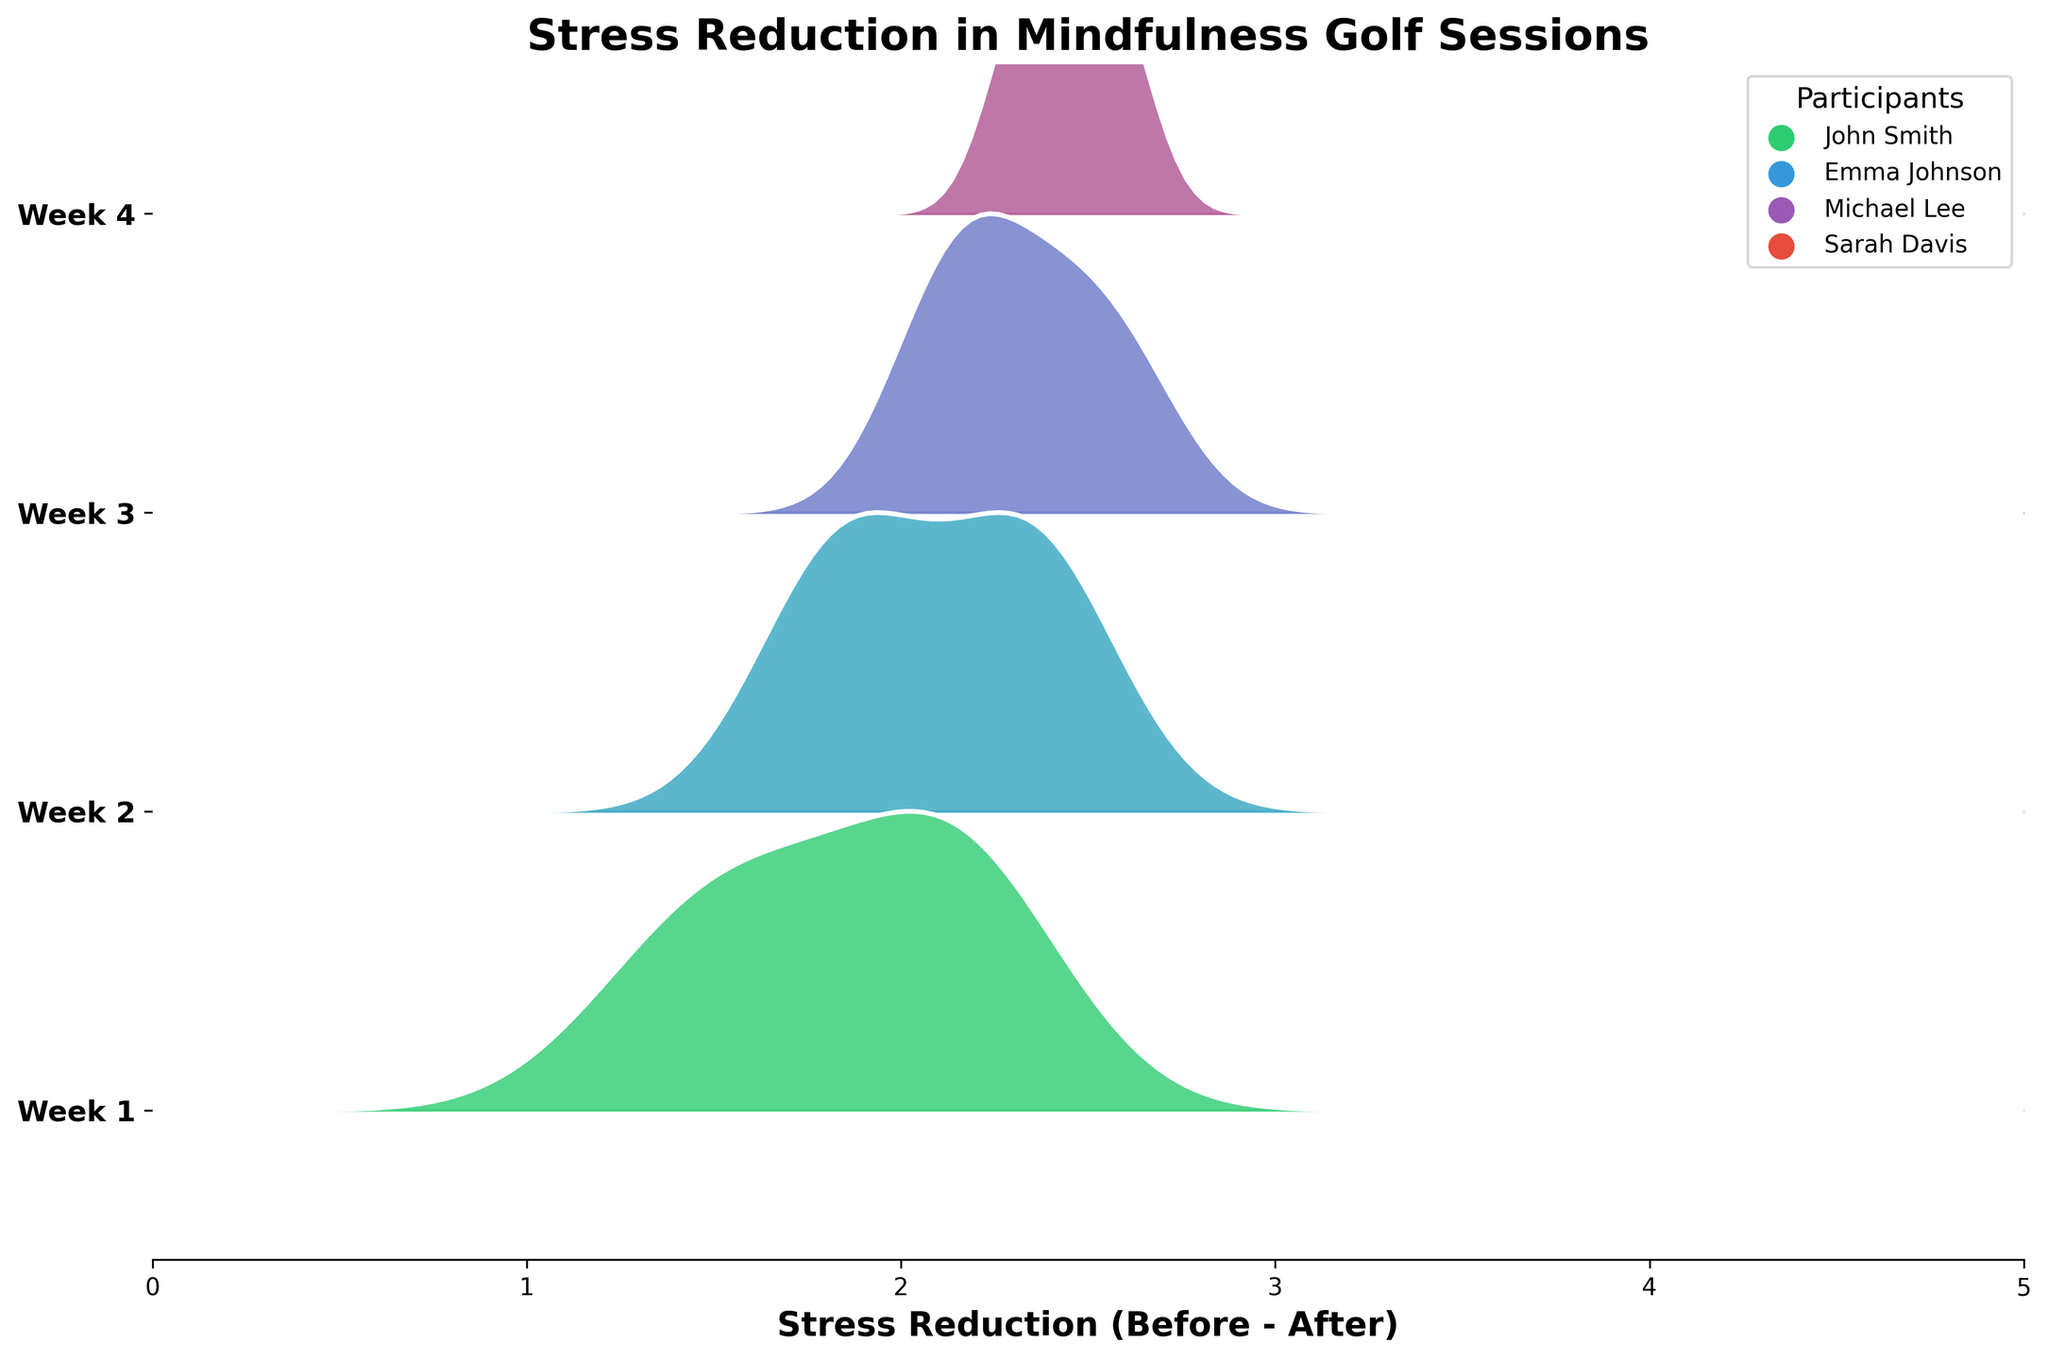What does the title of the plot indicate? The plot's title 'Stress Reduction in Mindfulness Golf Sessions' indicates that the figure showcases data related to the reduction in stress levels of participants before and after mindfulness golf sessions across several weeks.
Answer: Stress Reduction in Mindfulness Golf Sessions Which week displayed the greatest reduction in stress scores? To find when the greatest reduction occurred, we would look at the week with the highest peaks in the ridgeline plot. Typically, the height and spread of the ridgeline can suggest the extent of stress reduction. From the plot, Week 4 appears to have the highest peaks, indicating a greater reduction.
Answer: Week 4 How does the stress reduction from Week 1 compare to Week 4? Comparing the distributions, Week 4's ridgeline plot is taller and shifted more to the right compared to Week 1, indicating greater stress reduction. The height and position of the ridgeline suggest Week 4 has a significantly higher reduction.
Answer: Greater in Week 4 What is the range of stress reduction shown on the x-axis? The x-axis shows the stress reduction values, and according to the plot, it ranges from 0 to 5, representing the difference between stress scores before and after the sessions.
Answer: 0 to 5 Which participant seems to have the most significant individual impact on the plot? This can be inferred by looking at the legend and associating colors to observe contributions in each ridgeline. Participants like Sarah Davis (purple) show substantial reductions consistently week-over-week, suggesting significant individual impact.
Answer: Sarah Davis How did the stress reduction distribution change from Week 2 to Week 3? Examining the ridgelines, Week 2 has a moderate peak indicating some reduction, while Week 3 shows a higher peak that is more shifted to the right, suggesting increased stress reduction over time.
Answer: Increased in Week 3 What can be inferred about patterns in stress reduction over the four weeks? Observing trends, ridgeline peaks become higher and more right-shifted from Week 1 to Week 4, indicating a consistent improvement in stress reduction over time with the mindfulness golf sessions.
Answer: Consistent improvement over time How does Emma Johnson's stress reduction trend compare across the weeks? By referring to the specific color associated with Emma Johnson in the legend (blue), we see her ridgelines gradually shift more to the right each week, suggesting increasing stress reduction scores from Week 1 to Week 4.
Answer: Increasing trend Is there a particular week where stress reduction is less uniformly distributed? Ridgeline plots with lower, wider peaks indicate less uniform stress reduction. Here, Week 1 appears less uniform with a broader distribution, implying varied reduction scores among participants.
Answer: Week 1 Which week's ridgeline plot has the sharpest peak? Sharpness of the peak can be determined by the steepness and height in the plot. Week 4's ridgeline has the sharpest peak, indicating the highest consistency and greatest stress reduction among participants.
Answer: Week 4 